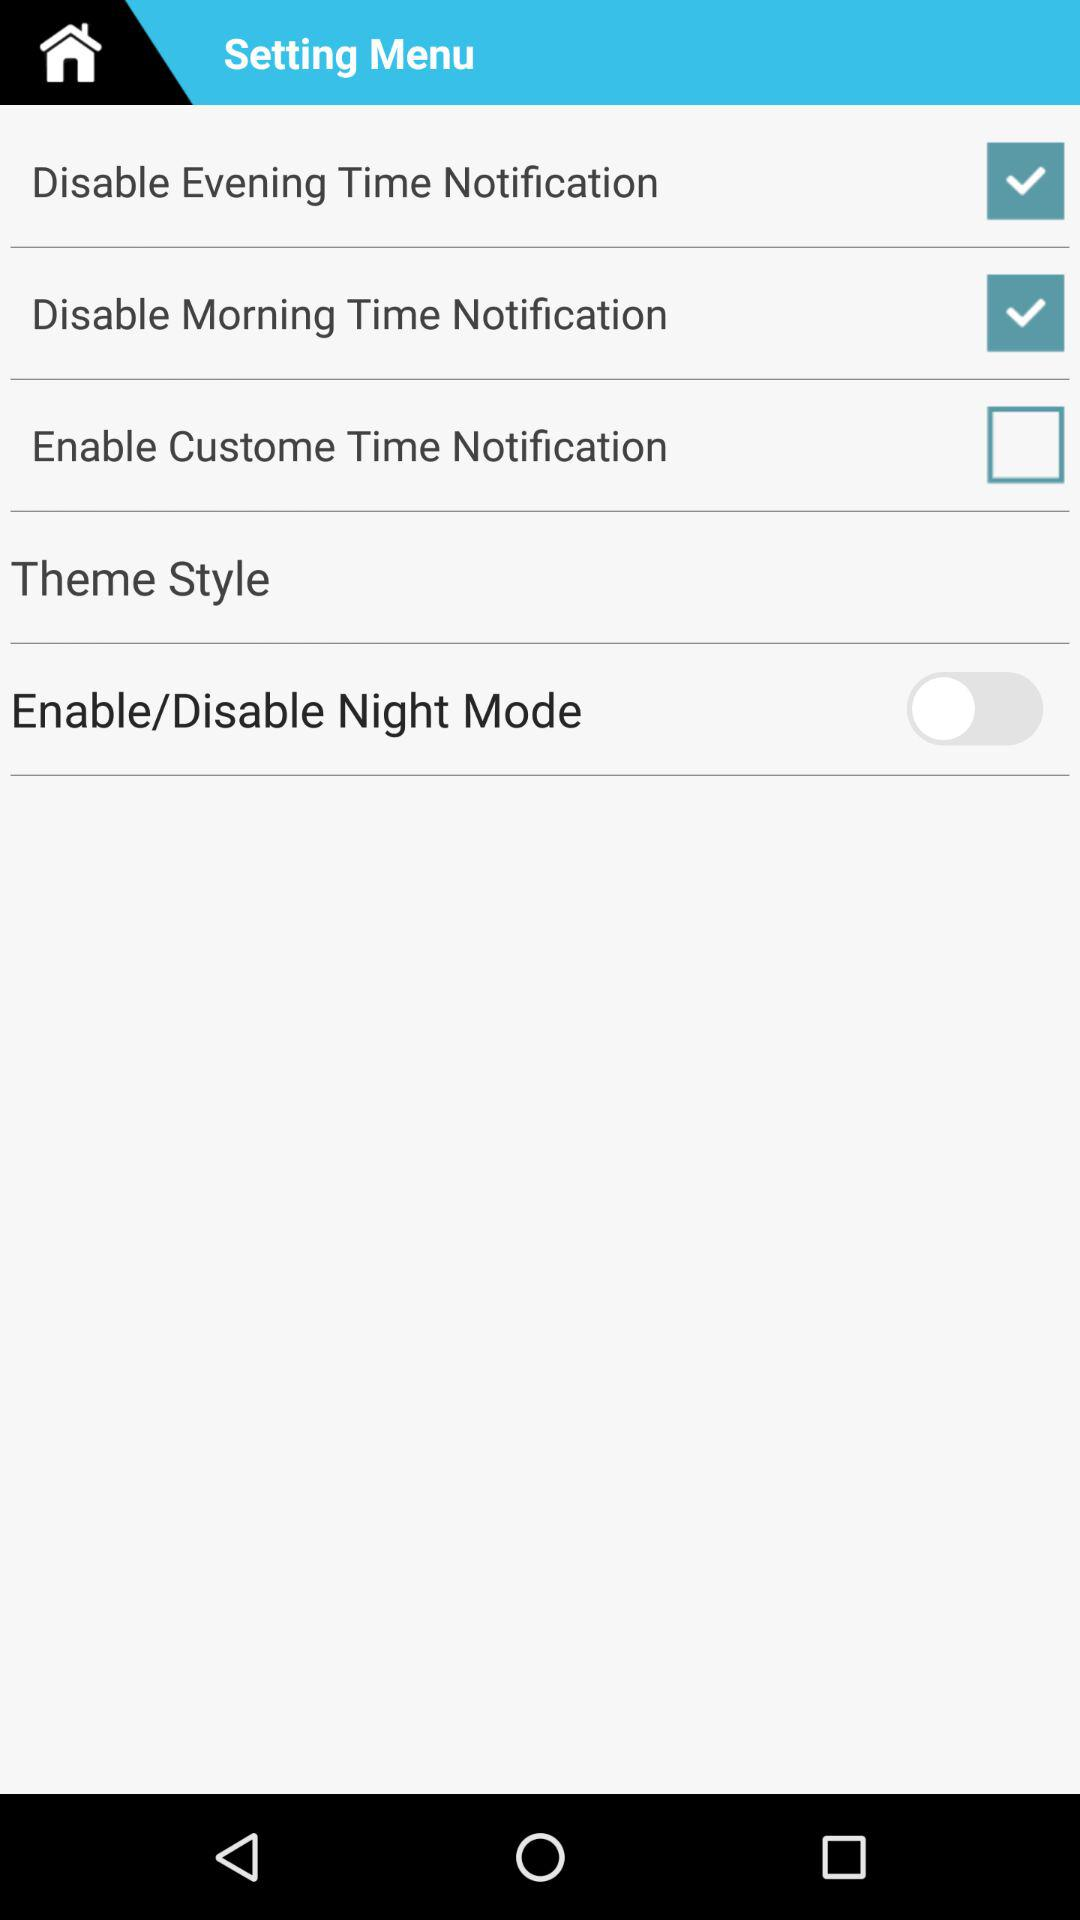What is the status of "Night Mode"? The status is "off". 